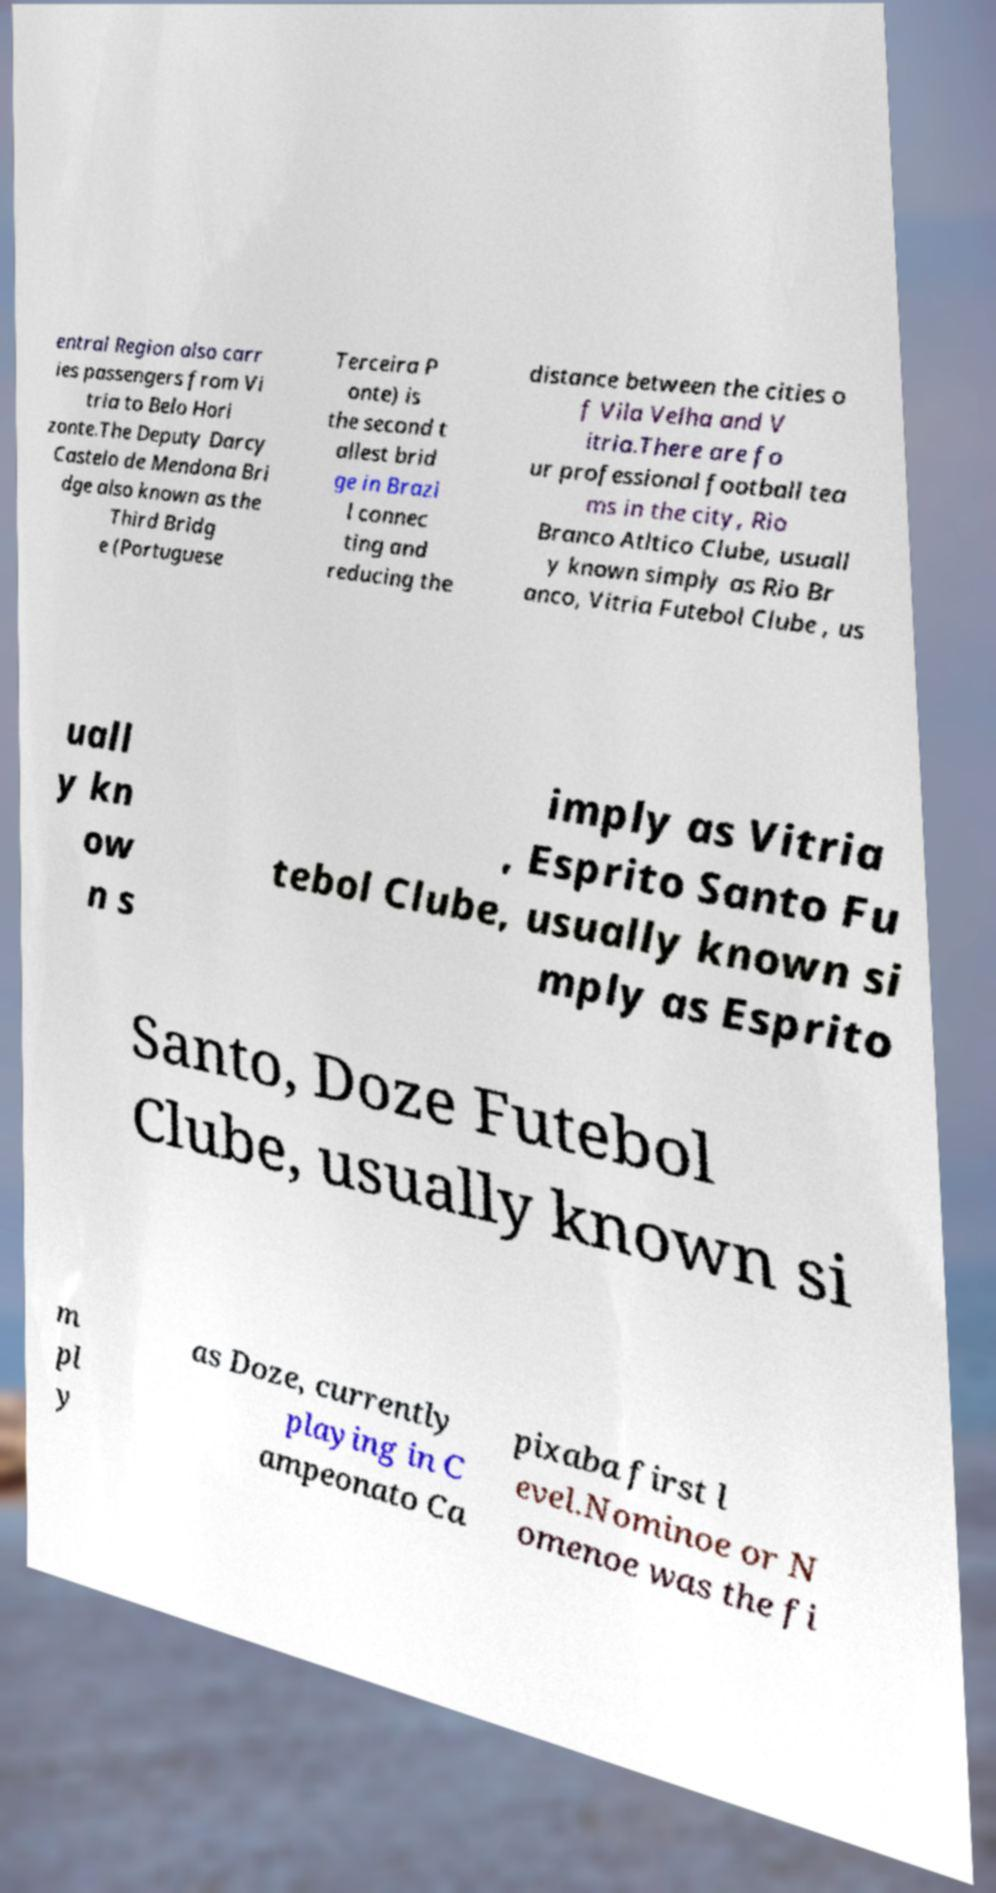There's text embedded in this image that I need extracted. Can you transcribe it verbatim? entral Region also carr ies passengers from Vi tria to Belo Hori zonte.The Deputy Darcy Castelo de Mendona Bri dge also known as the Third Bridg e (Portuguese Terceira P onte) is the second t allest brid ge in Brazi l connec ting and reducing the distance between the cities o f Vila Velha and V itria.There are fo ur professional football tea ms in the city, Rio Branco Atltico Clube, usuall y known simply as Rio Br anco, Vitria Futebol Clube , us uall y kn ow n s imply as Vitria , Esprito Santo Fu tebol Clube, usually known si mply as Esprito Santo, Doze Futebol Clube, usually known si m pl y as Doze, currently playing in C ampeonato Ca pixaba first l evel.Nominoe or N omenoe was the fi 